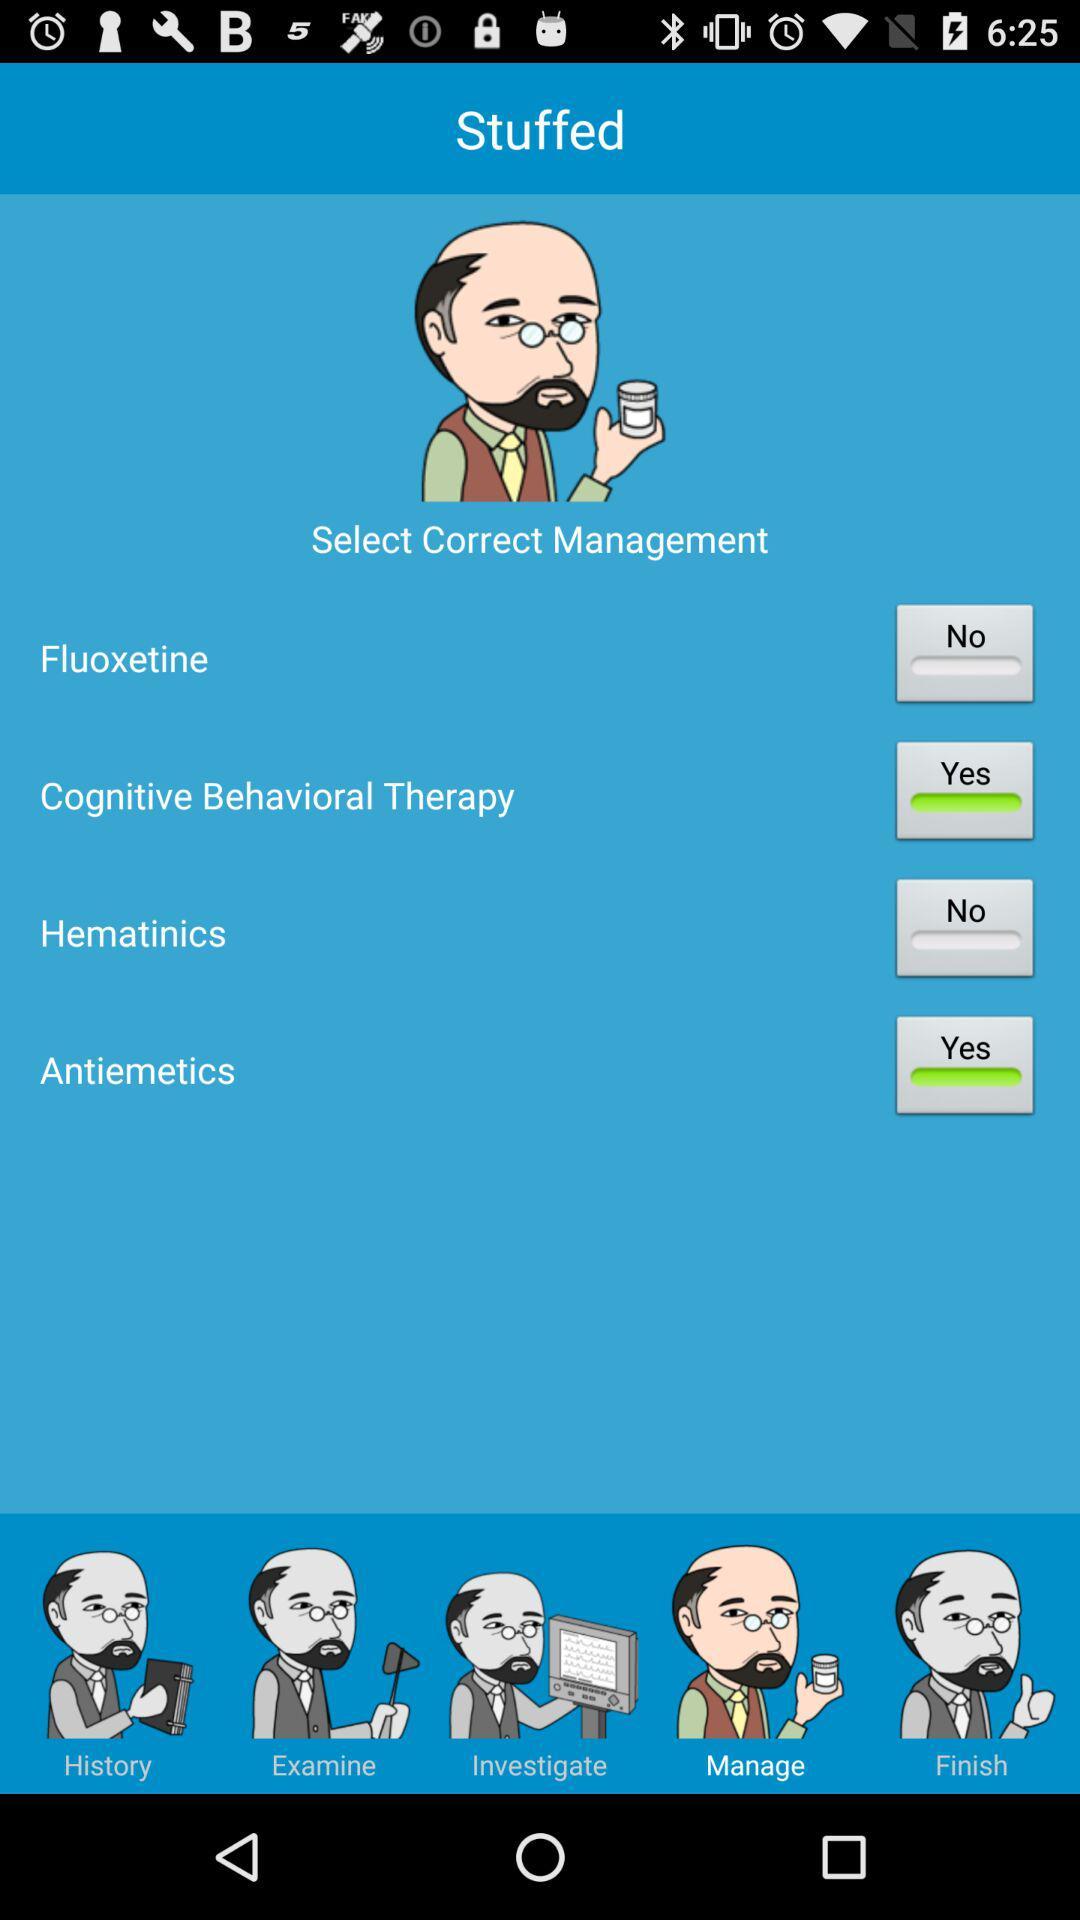Which types of management are selected? The types of management selected are "Cognitive Behavioral Therapy" and "Antiemetics". 